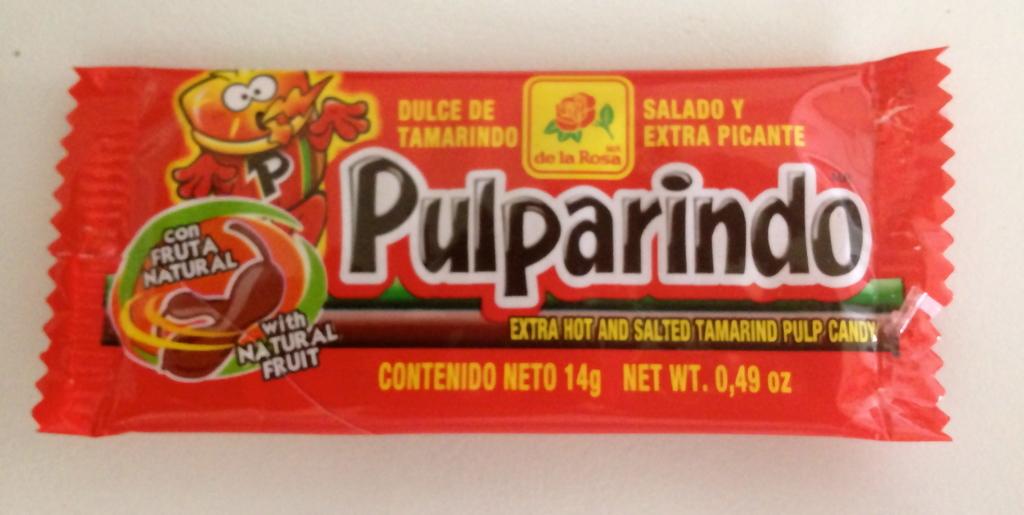What is the name of the product?
Ensure brevity in your answer.  Pulparindo. How many grams?
Provide a short and direct response. 14. 